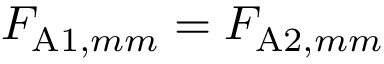Convert formula to latex. <formula><loc_0><loc_0><loc_500><loc_500>F _ { A 1 , m m } = F _ { A 2 , m m }</formula> 